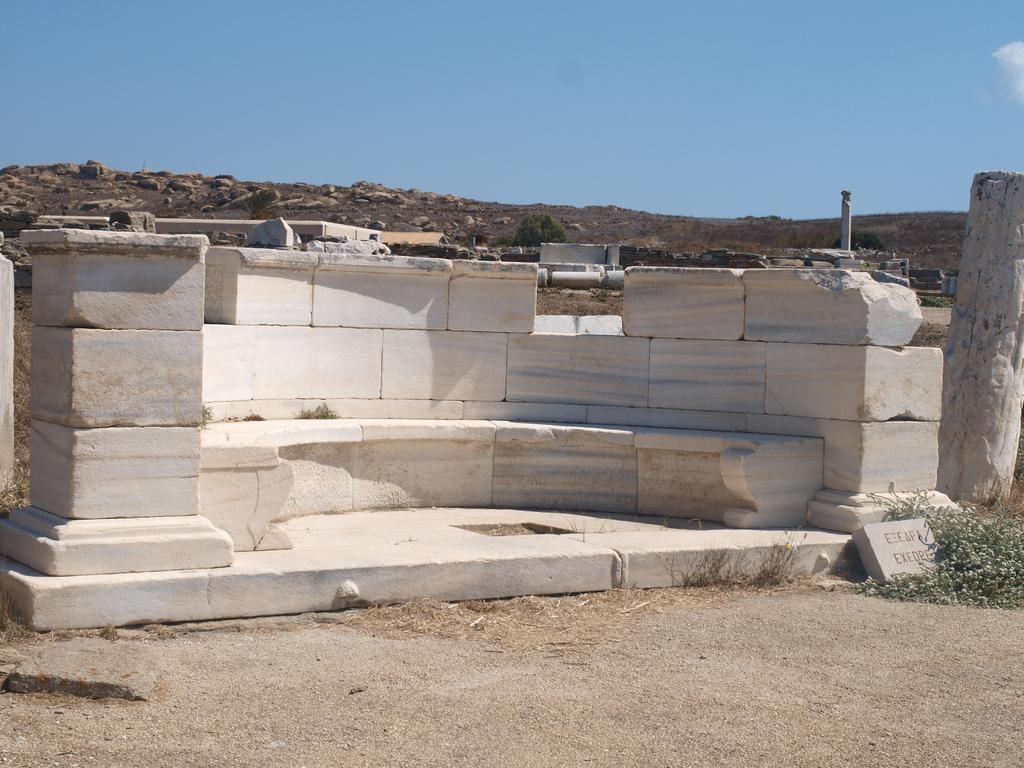Can you describe this image briefly? In the foreground of the image we can see sand. In the middle of the image we can see marbles. On the top of the image we can see the sky. 